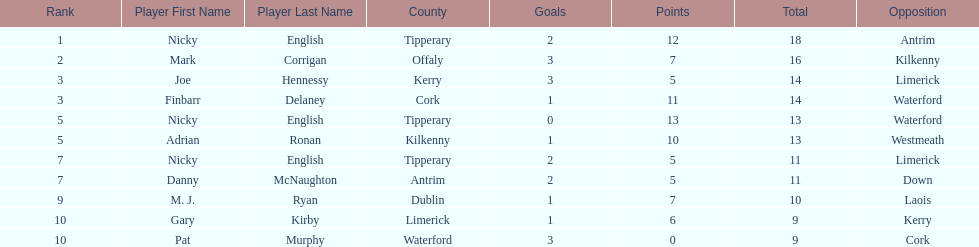How many people are on the list? 9. 